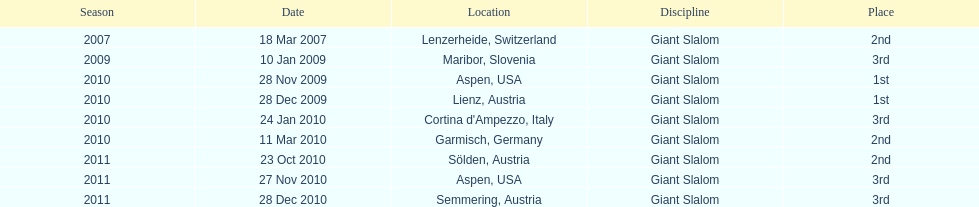What is the only location in the us? Aspen. 